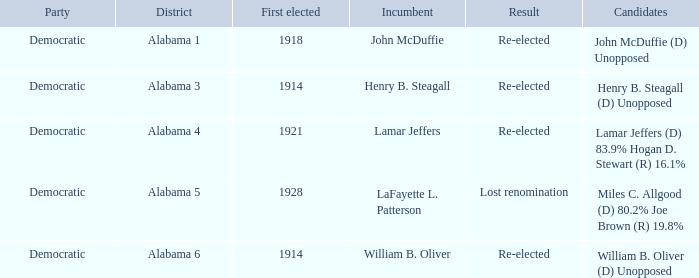What kind of party is the district in Alabama 1? Democratic. 